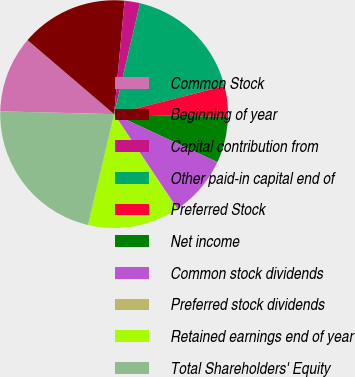Convert chart. <chart><loc_0><loc_0><loc_500><loc_500><pie_chart><fcel>Common Stock<fcel>Beginning of year<fcel>Capital contribution from<fcel>Other paid-in capital end of<fcel>Preferred Stock<fcel>Net income<fcel>Common stock dividends<fcel>Preferred stock dividends<fcel>Retained earnings end of year<fcel>Total Shareholders' Equity<nl><fcel>10.87%<fcel>15.21%<fcel>2.19%<fcel>17.38%<fcel>4.36%<fcel>6.53%<fcel>8.7%<fcel>0.02%<fcel>13.04%<fcel>21.72%<nl></chart> 